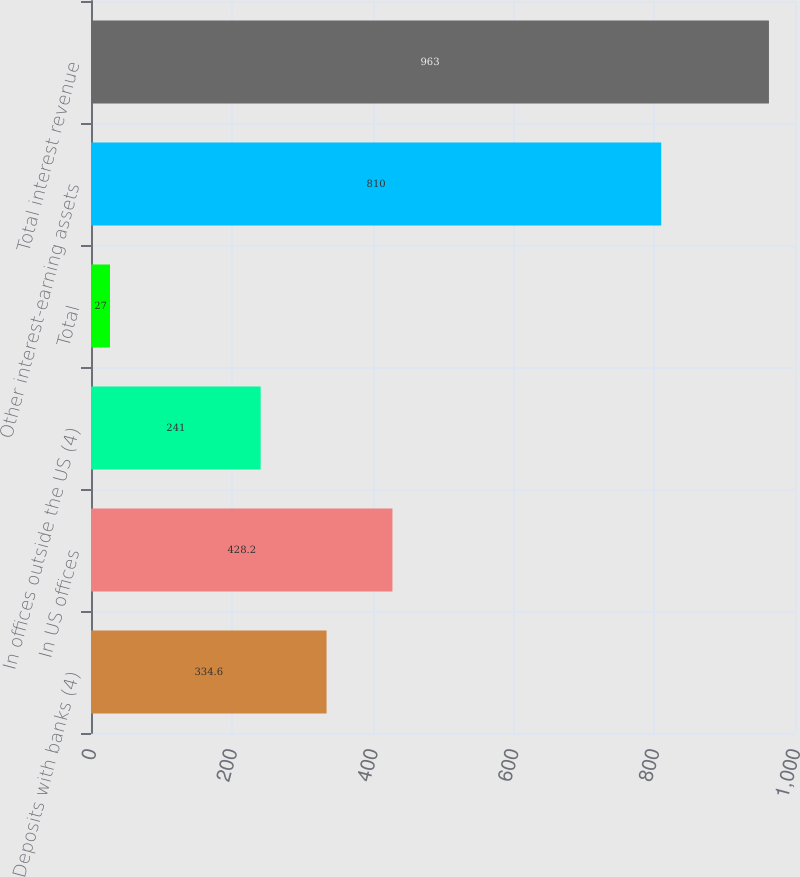<chart> <loc_0><loc_0><loc_500><loc_500><bar_chart><fcel>Deposits with banks (4)<fcel>In US offices<fcel>In offices outside the US (4)<fcel>Total<fcel>Other interest-earning assets<fcel>Total interest revenue<nl><fcel>334.6<fcel>428.2<fcel>241<fcel>27<fcel>810<fcel>963<nl></chart> 